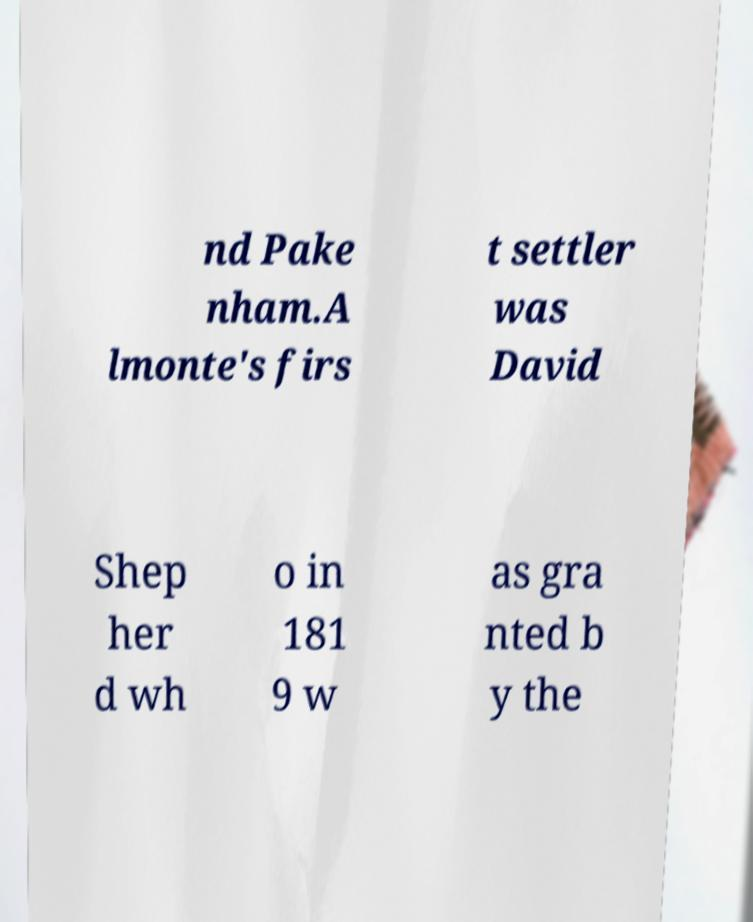Can you accurately transcribe the text from the provided image for me? nd Pake nham.A lmonte's firs t settler was David Shep her d wh o in 181 9 w as gra nted b y the 